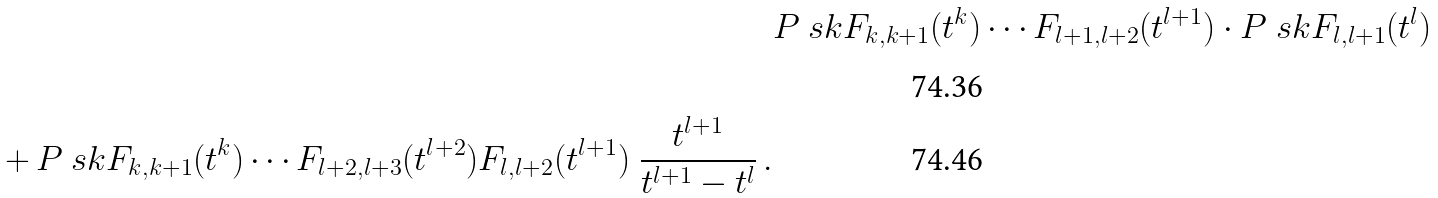<formula> <loc_0><loc_0><loc_500><loc_500>& P \ s k { F _ { k , k + 1 } ( t ^ { k } ) \cdots F _ { l + 1 , l + 2 } ( t ^ { l + 1 } ) } \cdot P \ s k { F _ { l , l + 1 } ( t ^ { l } ) } \, \\ + \, P \ s k { F _ { k , k + 1 } ( t ^ { k } ) \cdots F _ { l + 2 , l + 3 } ( t ^ { l + 2 } ) F _ { l , l + 2 } ( t ^ { l + 1 } ) } \ \frac { t ^ { l + 1 } } { t ^ { l + 1 } - t ^ { l } } \, .</formula> 